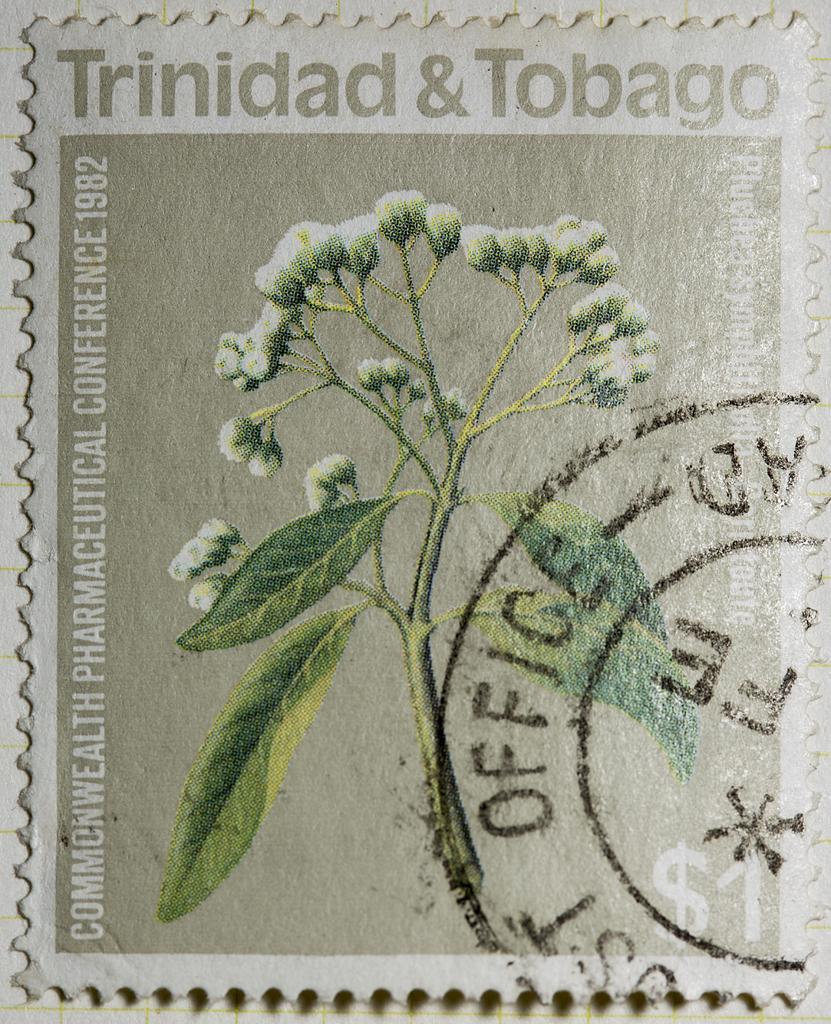In one or two sentences, can you explain what this image depicts? In the center of the image we can see a stem with leaves and flowers. On the right side of the image text is there. At the top of the image text is present. 